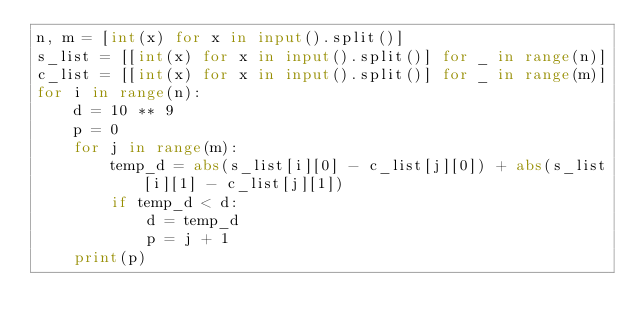Convert code to text. <code><loc_0><loc_0><loc_500><loc_500><_Python_>n, m = [int(x) for x in input().split()]
s_list = [[int(x) for x in input().split()] for _ in range(n)]
c_list = [[int(x) for x in input().split()] for _ in range(m)]
for i in range(n):
    d = 10 ** 9
    p = 0
    for j in range(m):
        temp_d = abs(s_list[i][0] - c_list[j][0]) + abs(s_list[i][1] - c_list[j][1])
        if temp_d < d:
            d = temp_d
            p = j + 1
    print(p)</code> 